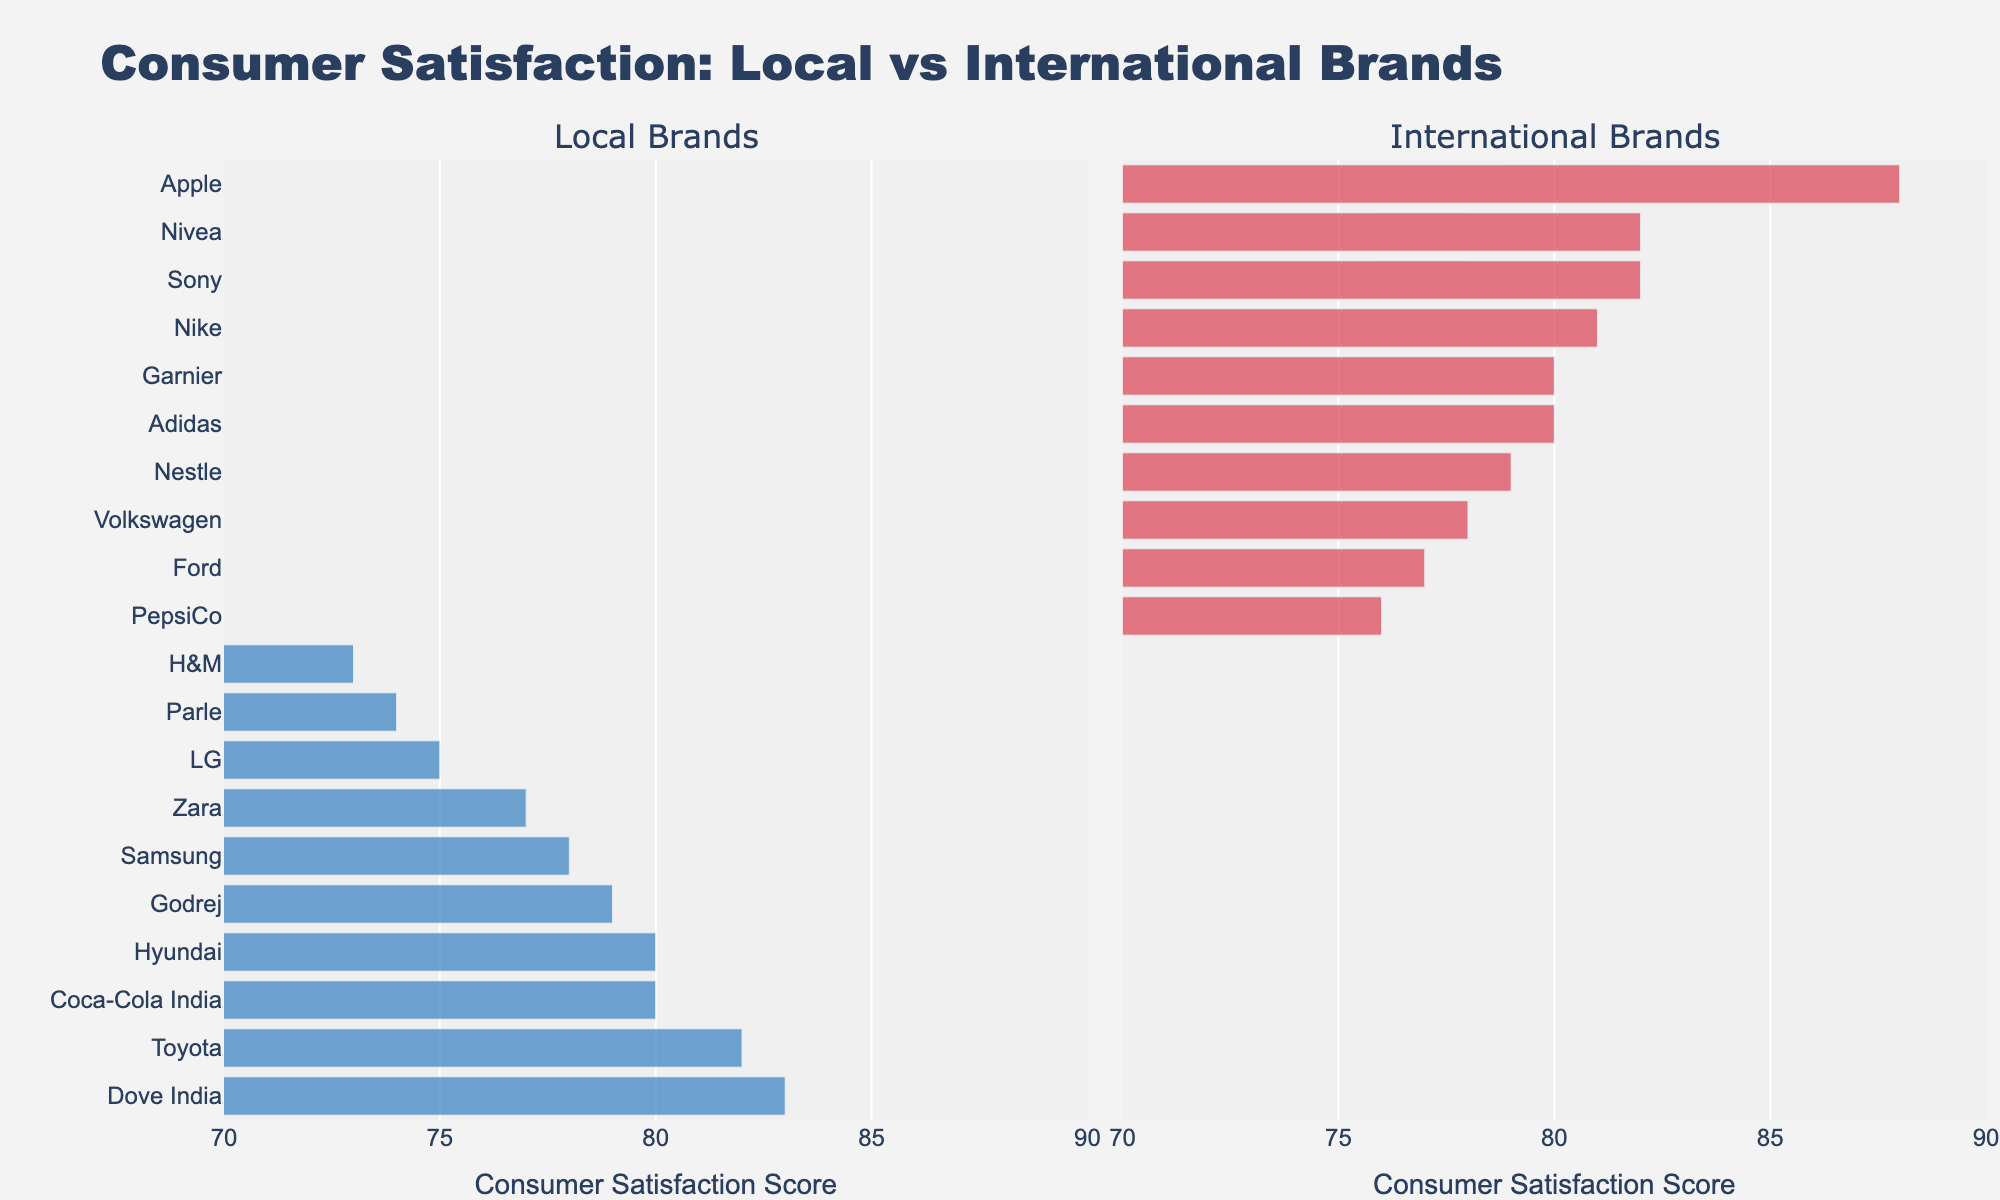How does the consumer satisfaction with local brands in the Electronics category compare to international brands in the same category? Looking at the bars in the Electronics section, the local brands LG and Samsung have consumer satisfaction scores of 75 and 78 respectively, while the international brands Sony and Apple have scores of 82 and 88 respectively. Therefore, international brands show higher satisfaction.
Answer: International brands show higher satisfaction Which brand has the highest consumer satisfaction score in the Personal Care category? Observing the Personal Care category, Dove India, a local brand, has the highest satisfaction score of 83.
Answer: Dove India Is there a significant difference between the satisfaction scores of Nike and Adidas in the Apparel category? Both Nike and Adidas are in the Apparel category. Nike has a consumer satisfaction score of 81 and Adidas has 80, leading to a difference of 1 point which is minimal.
Answer: Minimal difference (1 point) What is the average consumer satisfaction score for all local brands in the Automotive category? In the Automotive category, the local brands Toyota and Hyundai have scores of 82 and 80 respectively. The average is calculated as (82 + 80) / 2 = 81.
Answer: 81 Which international brand has the lowest consumer satisfaction score across all categories? Among all the categories, Ford in the Automotive section has the lowest satisfaction score for an international brand, which is 77.
Answer: Ford What is the average consumer satisfaction score for all brands in the Food & Beverage category? The Food & Beverage category includes Coca-Cola India (80), Parle (74), Nestle (79), and PepsiCo (76). The average is calculated as (80 + 74 + 79 + 76) / 4 = 77.25.
Answer: 77.25 Compare the highest consumer satisfaction scores between the local and international brands in the Apparel category. In the Apparel category, Zara has the highest score among local brands (77), and Nike has the highest score among international brands (81). Therefore, Nike’s score is higher.
Answer: Nike’s score is higher What is the total number of brands that have a consumer satisfaction score above 80? The brands with scores above 80 are Sony (82), Apple (88), Dove India (83), Nivea (82), LG (75), Samsung (78), Zara (77), Nike (81), Adidas (80), Coca-Cola India (80), Toyota (82), and Hyundai (80), which total to 12 brands.
Answer: 12 brands Which category has the highest overall consumer satisfaction score for international brands? Summing the scores for international brands in each category: Electronics (82 + 88 = 170), Apparel (81 + 80 = 161), Food & Beverage (79 + 76 = 155), Automotive (78 + 77 = 155), and Personal Care (82 + 80 = 162). Electronics has the highest overall score for international brands at 170.
Answer: Electronics What is the difference in consumer satisfaction scores between the highest and lowest ranked brands in the local category for the Food & Beverage section? In the Food & Beverage category, Coca-Cola India (80) and Parle (74) are the local brands. The difference is 80 - 74 = 6.
Answer: 6 